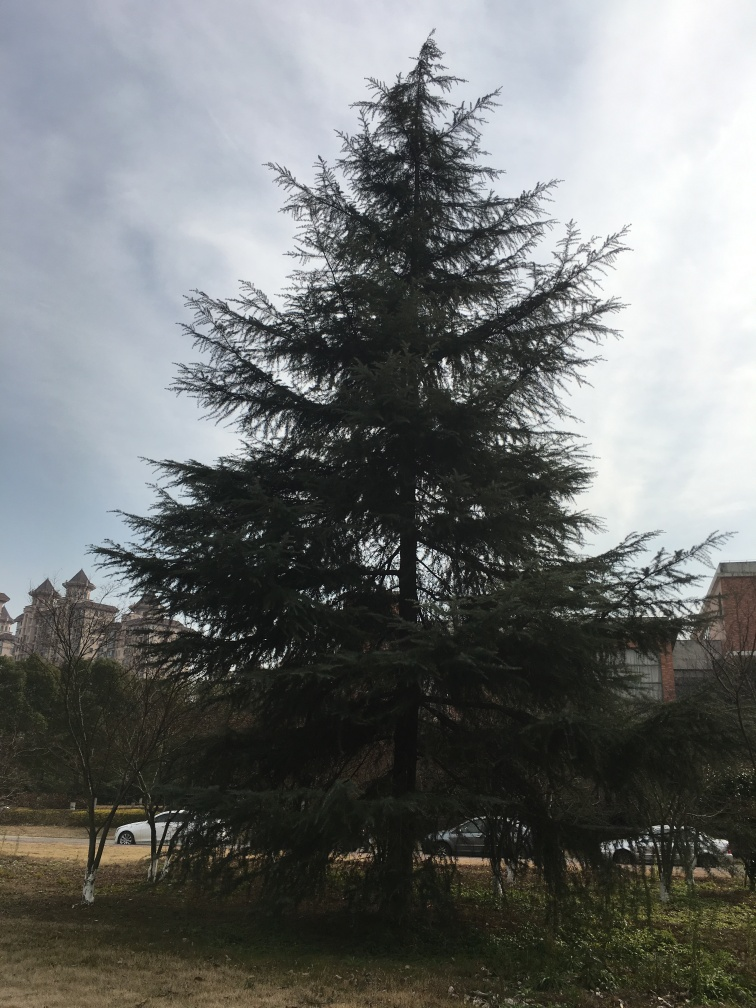How does the tree complement its surrounding environment? The tree brings a natural and organic element to the setting. Its evergreen branches contrast against the more structured and geometric forms of the urban backdrop, providing a connection to nature amidst the buildings. What time of year does the image suggest? Given the tree's full foliage and the clarity of the sky, it’s likely that the image was taken during the spring or summer months. 